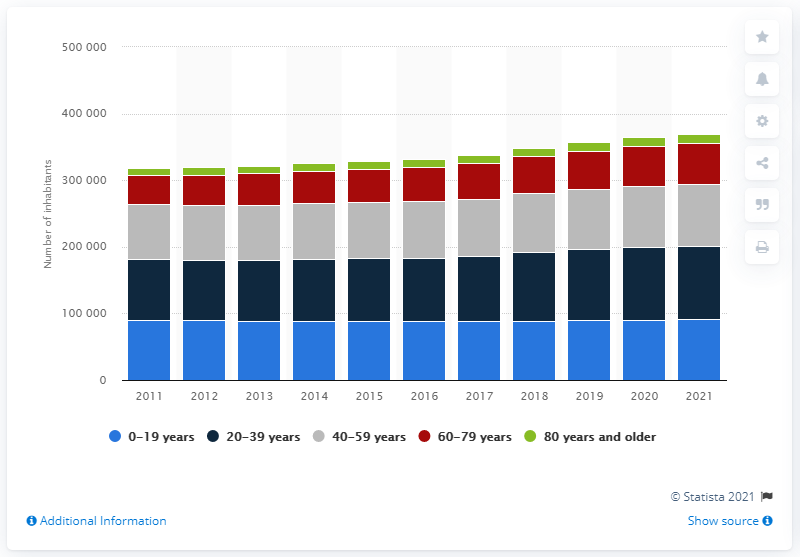Specify some key components in this picture. In 2021, the population of individuals aged 20 to 39 was approximately 110,477. 